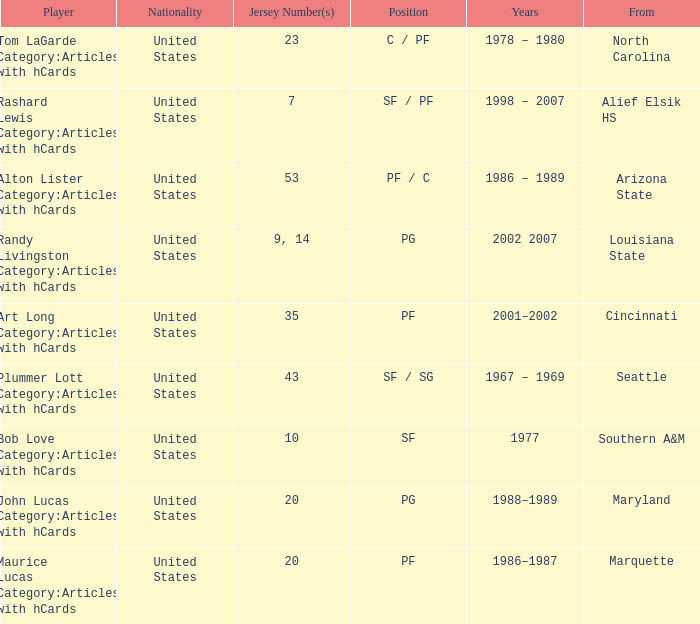The player from Alief Elsik Hs has what as a nationality? United States. 